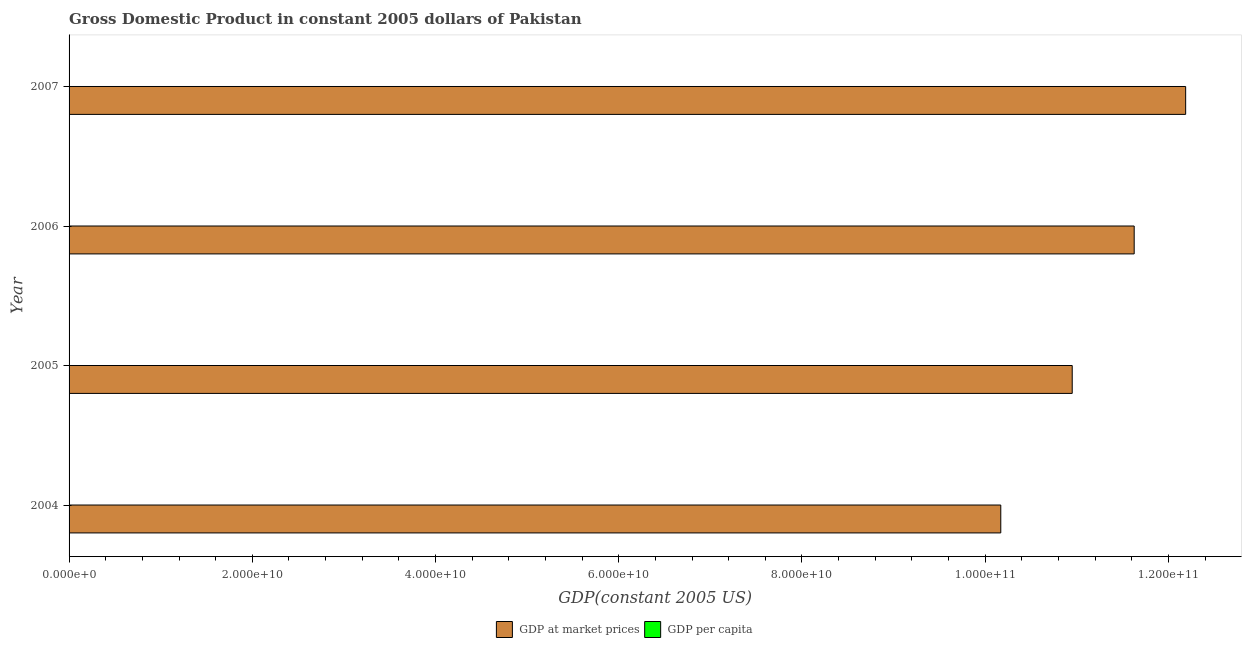How many different coloured bars are there?
Ensure brevity in your answer.  2. How many groups of bars are there?
Ensure brevity in your answer.  4. Are the number of bars per tick equal to the number of legend labels?
Make the answer very short. Yes. What is the gdp per capita in 2007?
Ensure brevity in your answer.  762.89. Across all years, what is the maximum gdp at market prices?
Ensure brevity in your answer.  1.22e+11. Across all years, what is the minimum gdp at market prices?
Your response must be concise. 1.02e+11. In which year was the gdp at market prices minimum?
Provide a succinct answer. 2004. What is the total gdp per capita in the graph?
Offer a terse response. 2896.55. What is the difference between the gdp per capita in 2004 and that in 2006?
Make the answer very short. -65.98. What is the difference between the gdp at market prices in 2004 and the gdp per capita in 2007?
Make the answer very short. 1.02e+11. What is the average gdp at market prices per year?
Provide a succinct answer. 1.12e+11. In the year 2006, what is the difference between the gdp at market prices and gdp per capita?
Your answer should be compact. 1.16e+11. In how many years, is the gdp per capita greater than 36000000000 US$?
Provide a short and direct response. 0. What is the difference between the highest and the second highest gdp at market prices?
Give a very brief answer. 5.62e+09. What is the difference between the highest and the lowest gdp at market prices?
Provide a succinct answer. 2.02e+1. Is the sum of the gdp per capita in 2006 and 2007 greater than the maximum gdp at market prices across all years?
Your answer should be very brief. No. What does the 2nd bar from the top in 2005 represents?
Offer a very short reply. GDP at market prices. What does the 1st bar from the bottom in 2004 represents?
Offer a terse response. GDP at market prices. How many bars are there?
Provide a short and direct response. 8. Are all the bars in the graph horizontal?
Ensure brevity in your answer.  Yes. Are the values on the major ticks of X-axis written in scientific E-notation?
Your answer should be compact. Yes. Does the graph contain any zero values?
Make the answer very short. No. Does the graph contain grids?
Your answer should be very brief. No. How many legend labels are there?
Offer a very short reply. 2. What is the title of the graph?
Make the answer very short. Gross Domestic Product in constant 2005 dollars of Pakistan. Does "Goods" appear as one of the legend labels in the graph?
Make the answer very short. No. What is the label or title of the X-axis?
Your response must be concise. GDP(constant 2005 US). What is the label or title of the Y-axis?
Ensure brevity in your answer.  Year. What is the GDP(constant 2005 US) in GDP at market prices in 2004?
Ensure brevity in your answer.  1.02e+11. What is the GDP(constant 2005 US) of GDP per capita in 2004?
Your answer should be compact. 676.82. What is the GDP(constant 2005 US) of GDP at market prices in 2005?
Offer a terse response. 1.10e+11. What is the GDP(constant 2005 US) in GDP per capita in 2005?
Give a very brief answer. 714.04. What is the GDP(constant 2005 US) of GDP at market prices in 2006?
Offer a very short reply. 1.16e+11. What is the GDP(constant 2005 US) in GDP per capita in 2006?
Offer a very short reply. 742.8. What is the GDP(constant 2005 US) in GDP at market prices in 2007?
Make the answer very short. 1.22e+11. What is the GDP(constant 2005 US) of GDP per capita in 2007?
Offer a terse response. 762.89. Across all years, what is the maximum GDP(constant 2005 US) in GDP at market prices?
Provide a succinct answer. 1.22e+11. Across all years, what is the maximum GDP(constant 2005 US) of GDP per capita?
Keep it short and to the point. 762.89. Across all years, what is the minimum GDP(constant 2005 US) in GDP at market prices?
Ensure brevity in your answer.  1.02e+11. Across all years, what is the minimum GDP(constant 2005 US) in GDP per capita?
Offer a terse response. 676.82. What is the total GDP(constant 2005 US) in GDP at market prices in the graph?
Provide a short and direct response. 4.49e+11. What is the total GDP(constant 2005 US) in GDP per capita in the graph?
Offer a terse response. 2896.55. What is the difference between the GDP(constant 2005 US) in GDP at market prices in 2004 and that in 2005?
Offer a very short reply. -7.80e+09. What is the difference between the GDP(constant 2005 US) in GDP per capita in 2004 and that in 2005?
Your response must be concise. -37.22. What is the difference between the GDP(constant 2005 US) in GDP at market prices in 2004 and that in 2006?
Provide a succinct answer. -1.46e+1. What is the difference between the GDP(constant 2005 US) of GDP per capita in 2004 and that in 2006?
Your answer should be compact. -65.98. What is the difference between the GDP(constant 2005 US) of GDP at market prices in 2004 and that in 2007?
Keep it short and to the point. -2.02e+1. What is the difference between the GDP(constant 2005 US) in GDP per capita in 2004 and that in 2007?
Your answer should be compact. -86.07. What is the difference between the GDP(constant 2005 US) of GDP at market prices in 2005 and that in 2006?
Your response must be concise. -6.76e+09. What is the difference between the GDP(constant 2005 US) of GDP per capita in 2005 and that in 2006?
Make the answer very short. -28.77. What is the difference between the GDP(constant 2005 US) of GDP at market prices in 2005 and that in 2007?
Offer a very short reply. -1.24e+1. What is the difference between the GDP(constant 2005 US) of GDP per capita in 2005 and that in 2007?
Keep it short and to the point. -48.86. What is the difference between the GDP(constant 2005 US) in GDP at market prices in 2006 and that in 2007?
Make the answer very short. -5.62e+09. What is the difference between the GDP(constant 2005 US) in GDP per capita in 2006 and that in 2007?
Your answer should be very brief. -20.09. What is the difference between the GDP(constant 2005 US) of GDP at market prices in 2004 and the GDP(constant 2005 US) of GDP per capita in 2005?
Ensure brevity in your answer.  1.02e+11. What is the difference between the GDP(constant 2005 US) of GDP at market prices in 2004 and the GDP(constant 2005 US) of GDP per capita in 2006?
Ensure brevity in your answer.  1.02e+11. What is the difference between the GDP(constant 2005 US) in GDP at market prices in 2004 and the GDP(constant 2005 US) in GDP per capita in 2007?
Ensure brevity in your answer.  1.02e+11. What is the difference between the GDP(constant 2005 US) of GDP at market prices in 2005 and the GDP(constant 2005 US) of GDP per capita in 2006?
Keep it short and to the point. 1.10e+11. What is the difference between the GDP(constant 2005 US) of GDP at market prices in 2005 and the GDP(constant 2005 US) of GDP per capita in 2007?
Offer a terse response. 1.10e+11. What is the difference between the GDP(constant 2005 US) in GDP at market prices in 2006 and the GDP(constant 2005 US) in GDP per capita in 2007?
Your answer should be very brief. 1.16e+11. What is the average GDP(constant 2005 US) in GDP at market prices per year?
Offer a very short reply. 1.12e+11. What is the average GDP(constant 2005 US) of GDP per capita per year?
Your answer should be compact. 724.14. In the year 2004, what is the difference between the GDP(constant 2005 US) of GDP at market prices and GDP(constant 2005 US) of GDP per capita?
Ensure brevity in your answer.  1.02e+11. In the year 2005, what is the difference between the GDP(constant 2005 US) of GDP at market prices and GDP(constant 2005 US) of GDP per capita?
Make the answer very short. 1.10e+11. In the year 2006, what is the difference between the GDP(constant 2005 US) in GDP at market prices and GDP(constant 2005 US) in GDP per capita?
Your answer should be compact. 1.16e+11. In the year 2007, what is the difference between the GDP(constant 2005 US) in GDP at market prices and GDP(constant 2005 US) in GDP per capita?
Make the answer very short. 1.22e+11. What is the ratio of the GDP(constant 2005 US) in GDP at market prices in 2004 to that in 2005?
Provide a succinct answer. 0.93. What is the ratio of the GDP(constant 2005 US) in GDP per capita in 2004 to that in 2005?
Your response must be concise. 0.95. What is the ratio of the GDP(constant 2005 US) in GDP at market prices in 2004 to that in 2006?
Give a very brief answer. 0.87. What is the ratio of the GDP(constant 2005 US) in GDP per capita in 2004 to that in 2006?
Provide a succinct answer. 0.91. What is the ratio of the GDP(constant 2005 US) of GDP at market prices in 2004 to that in 2007?
Your response must be concise. 0.83. What is the ratio of the GDP(constant 2005 US) of GDP per capita in 2004 to that in 2007?
Your answer should be compact. 0.89. What is the ratio of the GDP(constant 2005 US) in GDP at market prices in 2005 to that in 2006?
Offer a very short reply. 0.94. What is the ratio of the GDP(constant 2005 US) in GDP per capita in 2005 to that in 2006?
Your response must be concise. 0.96. What is the ratio of the GDP(constant 2005 US) of GDP at market prices in 2005 to that in 2007?
Offer a terse response. 0.9. What is the ratio of the GDP(constant 2005 US) in GDP per capita in 2005 to that in 2007?
Keep it short and to the point. 0.94. What is the ratio of the GDP(constant 2005 US) of GDP at market prices in 2006 to that in 2007?
Make the answer very short. 0.95. What is the ratio of the GDP(constant 2005 US) of GDP per capita in 2006 to that in 2007?
Make the answer very short. 0.97. What is the difference between the highest and the second highest GDP(constant 2005 US) of GDP at market prices?
Your answer should be compact. 5.62e+09. What is the difference between the highest and the second highest GDP(constant 2005 US) of GDP per capita?
Offer a terse response. 20.09. What is the difference between the highest and the lowest GDP(constant 2005 US) of GDP at market prices?
Your response must be concise. 2.02e+1. What is the difference between the highest and the lowest GDP(constant 2005 US) of GDP per capita?
Ensure brevity in your answer.  86.07. 